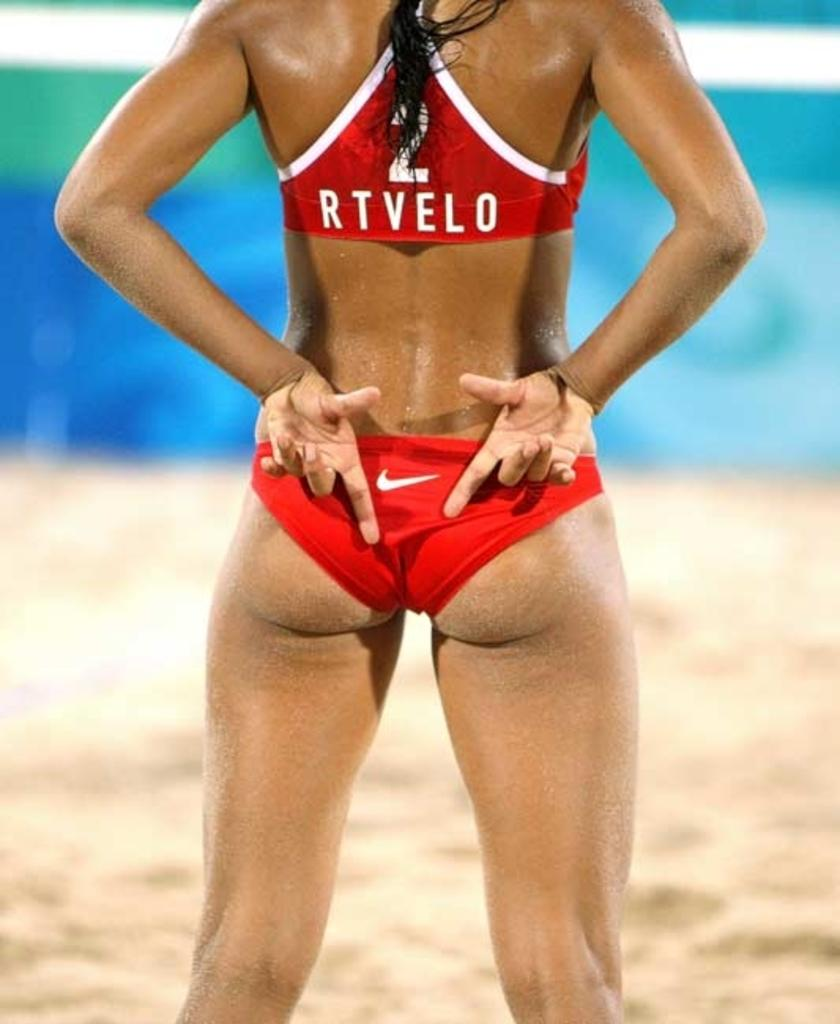<image>
Give a short and clear explanation of the subsequent image. Woman standing in sand and wearing a swimsuit that says RTVELO. 